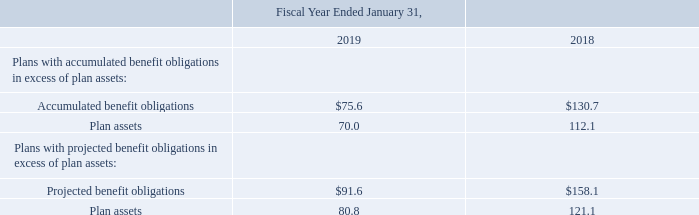On a worldwide basis, the Company's defined benefit pension plans were 88% funded as of January 31, 2019.
As of January 31, 2019, the aggregate accumulated benefit obligation was $85.1 million for the defined benefit pension plans compared to $139.5 million as of January 31, 2018. Included in the aggregate data in the following tables are the amounts applicable to the Company's defined benefit pension plans, with accumulated benefit obligations in excess of plan assets, as well as plans with projected benefit obligations in excess of plan assets. Amounts related to such plans at the end of each period were as follows: because their exercise prices are higher than the average market value of Autodesk’s stock during the fiscal year.
What was the defined benefit pension plans as of January 31, 2019? As of january 31, 2019, the aggregate accumulated benefit obligation was $85.1 million for the defined benefit pension plans compared to $139.5 million as of january 31, 2018. How much of the company's defined benefit pension plans were funded as of January 31, 2019? 88%. How much are the projected benefit obligations for 2019?
Answer scale should be: million. $91.6. How much is the percentage change in the projected benefit obligations from 2018 to 2019?
Answer scale should be: percent. ((91.6-158.1)/158.1)
Answer: -42.06. What was the change in the aggregate accumulated benefit obligation from 2018 to 2019?
Answer scale should be: million. 139.5-85.1
Answer: 54.4. How much did the plan assets change from 2018 to 2019 for plans with accumulated benefit obligations in excess of plan assets?
Answer scale should be: percent. (70 - 112.1)/112.1 
Answer: -37.56. 